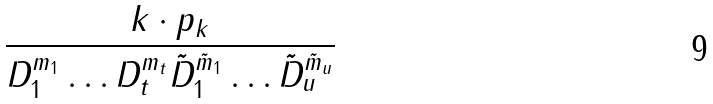<formula> <loc_0><loc_0><loc_500><loc_500>\frac { k \cdot p _ { k } } { D _ { 1 } ^ { m _ { 1 } } \dots D _ { t } ^ { m _ { t } } \tilde { D } _ { 1 } ^ { \tilde { m } _ { 1 } } \dots \tilde { D } _ { u } ^ { \tilde { m } _ { u } } }</formula> 